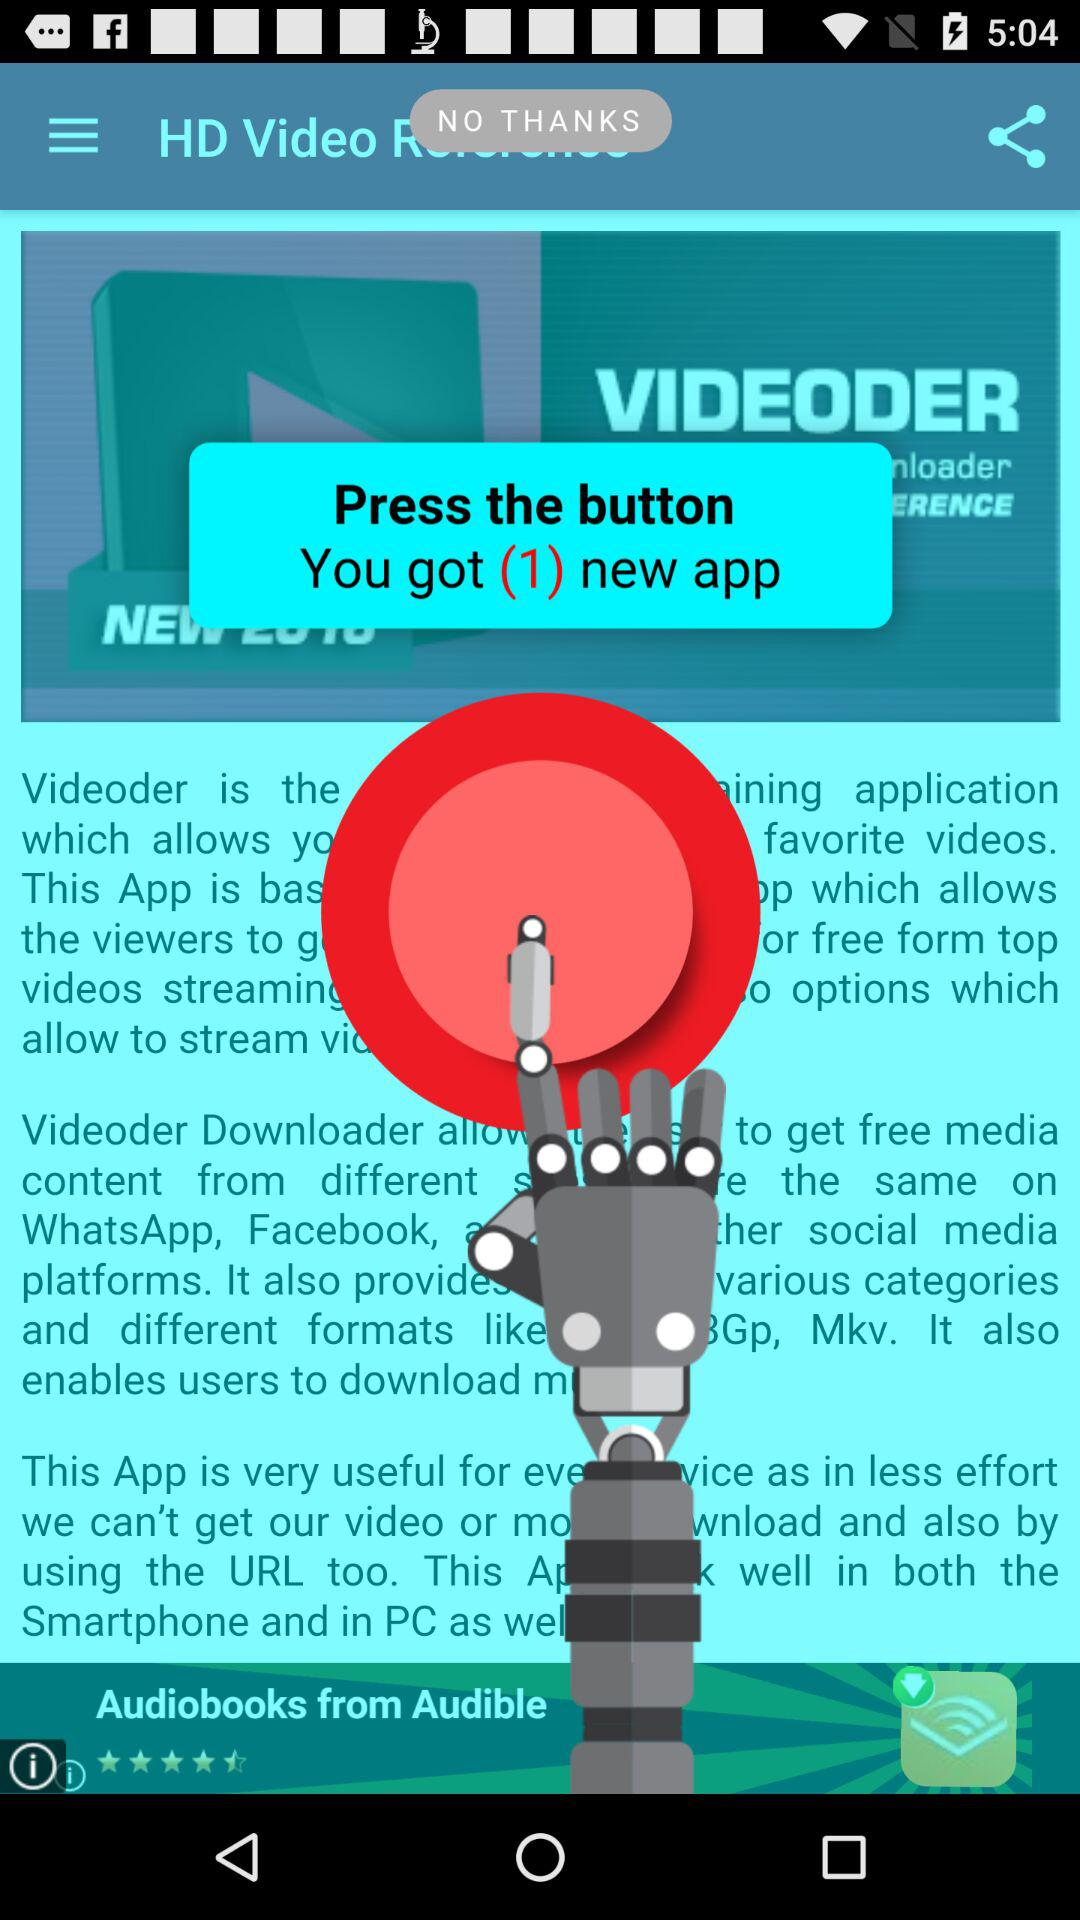How many new applications do we get? You get one new application. 